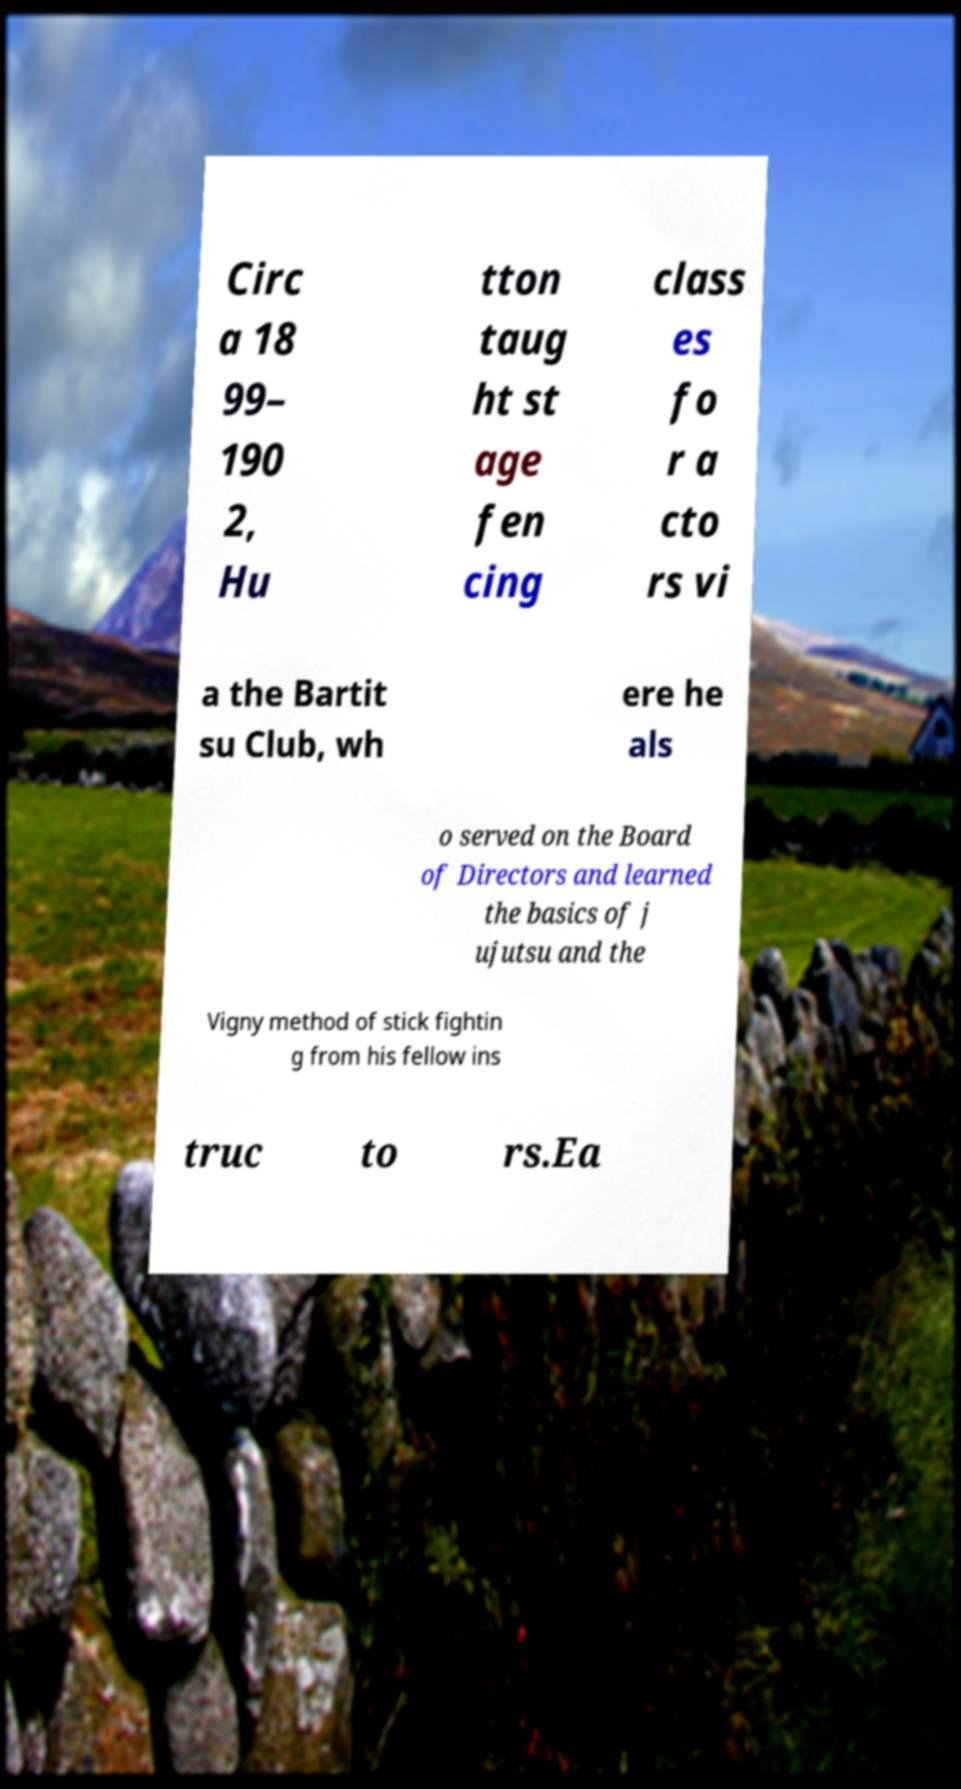For documentation purposes, I need the text within this image transcribed. Could you provide that? Circ a 18 99– 190 2, Hu tton taug ht st age fen cing class es fo r a cto rs vi a the Bartit su Club, wh ere he als o served on the Board of Directors and learned the basics of j ujutsu and the Vigny method of stick fightin g from his fellow ins truc to rs.Ea 